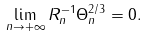<formula> <loc_0><loc_0><loc_500><loc_500>\lim _ { n \to + \infty } R _ { n } ^ { - 1 } \Theta _ { n } ^ { 2 / 3 } = 0 .</formula> 